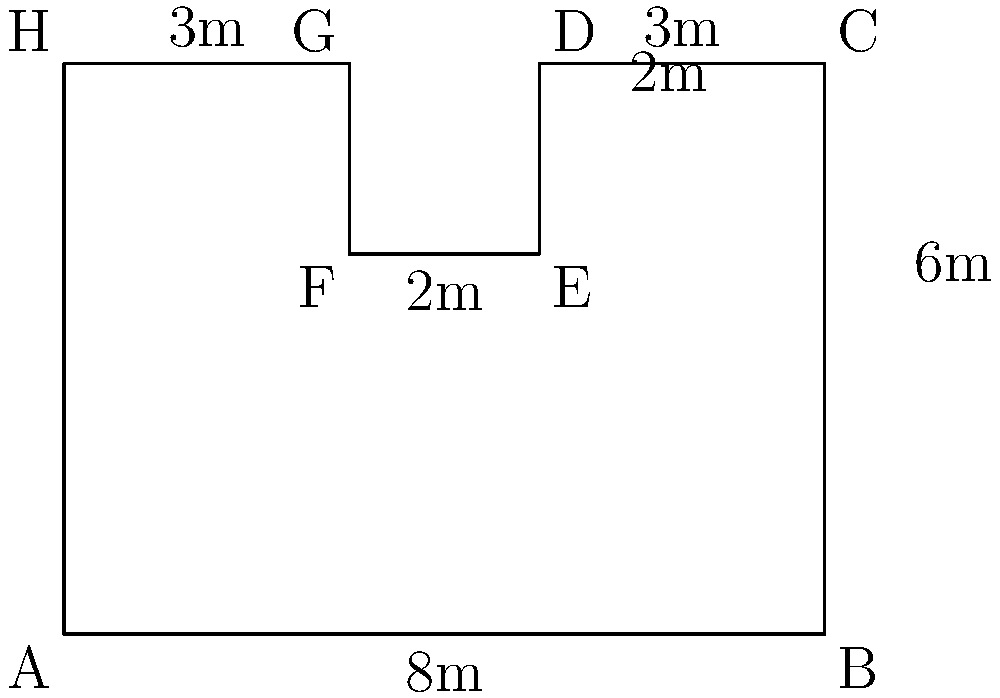You've designed an irregularly shaped insect breeding enclosure for your cattle farm. The enclosure's shape is shown in the diagram above, with dimensions in meters. What is the perimeter of this enclosure? To find the perimeter of the irregular shape, we need to sum up the lengths of all sides:

1. Side AB: 8m
2. Side BC: 6m
3. Side CD: 3m
4. Side DE: 2m
5. Side EF: 2m
6. Side FG: 2m (same as DE)
7. Side GH: 3m
8. Side HA: 6m (same as BC)

Now, let's add all these lengths:

$$ \text{Perimeter} = 8 + 6 + 3 + 2 + 2 + 2 + 3 + 6 = 32 \text{ meters} $$

Therefore, the perimeter of the insect breeding enclosure is 32 meters.
Answer: 32 meters 